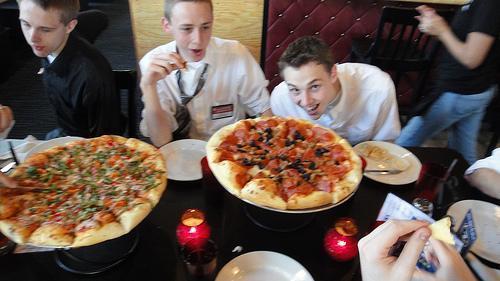How many candles on the table?
Give a very brief answer. 2. 